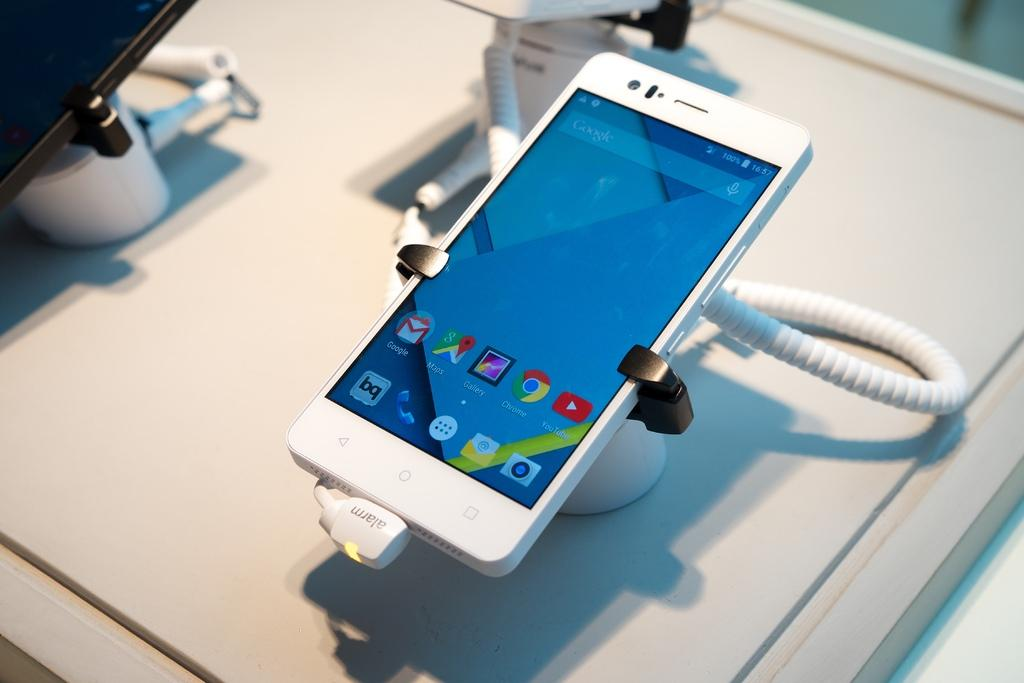<image>
Share a concise interpretation of the image provided. A phone secured to a table with 100% battery. 